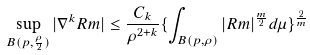<formula> <loc_0><loc_0><loc_500><loc_500>\sup _ { B ( p , \frac { \rho } { 2 } ) } | \nabla ^ { k } R m | \leq \frac { C _ { k } } { \rho ^ { 2 + k } } \{ \int _ { B ( p , \rho ) } | R m | ^ { \frac { m } { 2 } } d \mu \} ^ { \frac { 2 } { m } }</formula> 